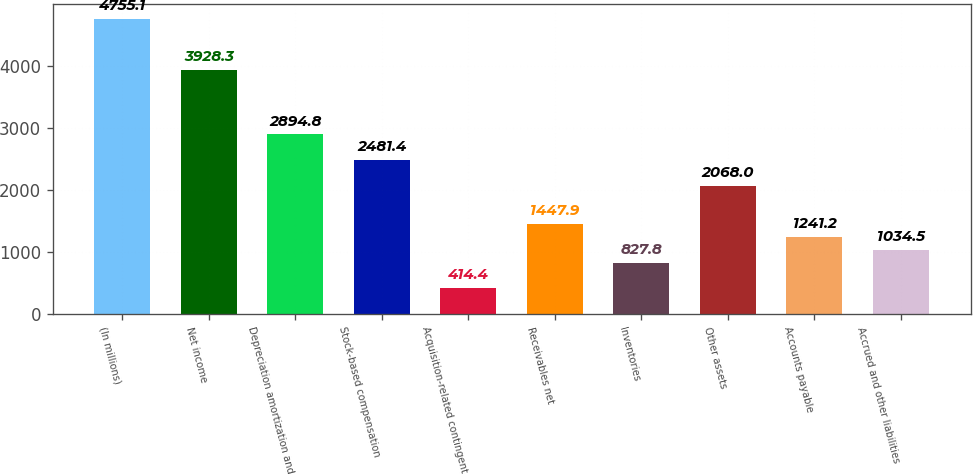Convert chart to OTSL. <chart><loc_0><loc_0><loc_500><loc_500><bar_chart><fcel>(In millions)<fcel>Net income<fcel>Depreciation amortization and<fcel>Stock-based compensation<fcel>Acquisition-related contingent<fcel>Receivables net<fcel>Inventories<fcel>Other assets<fcel>Accounts payable<fcel>Accrued and other liabilities<nl><fcel>4755.1<fcel>3928.3<fcel>2894.8<fcel>2481.4<fcel>414.4<fcel>1447.9<fcel>827.8<fcel>2068<fcel>1241.2<fcel>1034.5<nl></chart> 